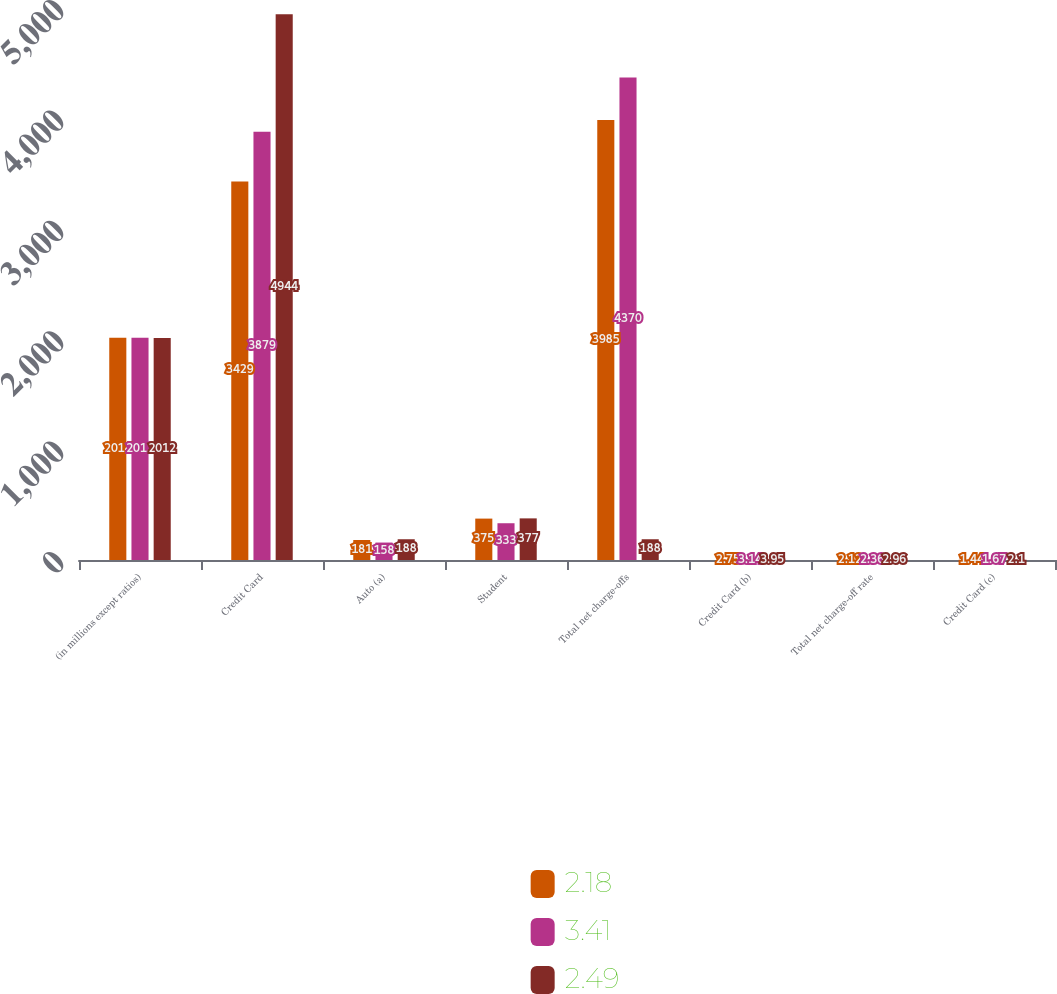Convert chart to OTSL. <chart><loc_0><loc_0><loc_500><loc_500><stacked_bar_chart><ecel><fcel>(in millions except ratios)<fcel>Credit Card<fcel>Auto (a)<fcel>Student<fcel>Total net charge-offs<fcel>Credit Card (b)<fcel>Total net charge-off rate<fcel>Credit Card (c)<nl><fcel>2.18<fcel>2014<fcel>3429<fcel>181<fcel>375<fcel>3985<fcel>2.75<fcel>2.12<fcel>1.44<nl><fcel>3.41<fcel>2013<fcel>3879<fcel>158<fcel>333<fcel>4370<fcel>3.14<fcel>2.36<fcel>1.67<nl><fcel>2.49<fcel>2012<fcel>4944<fcel>188<fcel>377<fcel>188<fcel>3.95<fcel>2.96<fcel>2.1<nl></chart> 